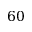<formula> <loc_0><loc_0><loc_500><loc_500>6 0</formula> 